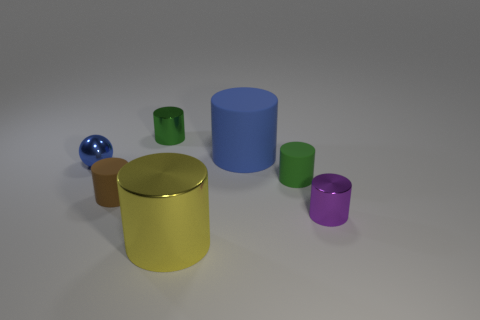Subtract all small green cylinders. How many cylinders are left? 4 Add 1 tiny spheres. How many objects exist? 8 Subtract all blue cylinders. How many cylinders are left? 5 Subtract 3 cylinders. How many cylinders are left? 3 Subtract all red rubber cylinders. Subtract all small green rubber objects. How many objects are left? 6 Add 4 big blue matte objects. How many big blue matte objects are left? 5 Add 7 tiny brown cylinders. How many tiny brown cylinders exist? 8 Subtract 1 brown cylinders. How many objects are left? 6 Subtract all cylinders. How many objects are left? 1 Subtract all purple cylinders. Subtract all gray spheres. How many cylinders are left? 5 